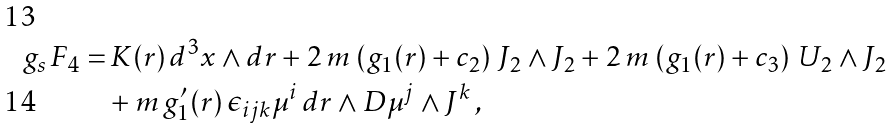<formula> <loc_0><loc_0><loc_500><loc_500>g _ { s } \, F _ { 4 } = & \, K ( r ) \, d ^ { 3 } x \wedge d r + 2 \, m \, \left ( g _ { 1 } ( r ) + c _ { 2 } \right ) \, J _ { 2 } \wedge J _ { 2 } + 2 \, m \, \left ( g _ { 1 } ( r ) + c _ { 3 } \right ) \, U _ { 2 } \wedge J _ { 2 } \\ & + m \, g _ { 1 } ^ { \prime } ( r ) \, \epsilon _ { i j k } \mu ^ { i } \, d r \wedge D \mu ^ { j } \wedge J ^ { k } \, ,</formula> 